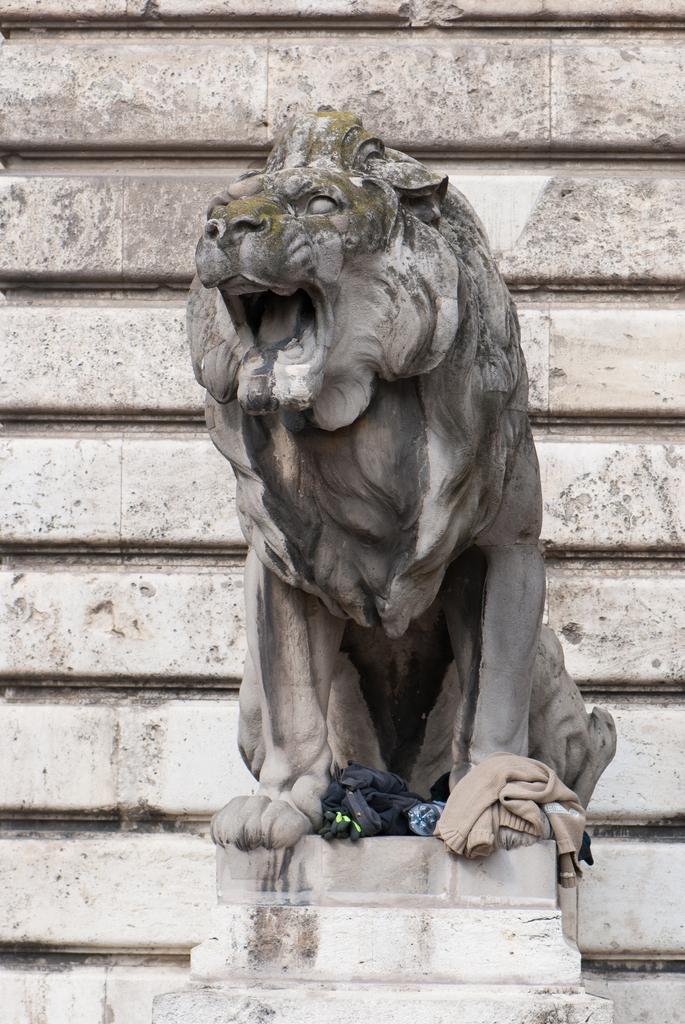What animal is depicted in the image? There is a depiction of a lion in the image. What else can be seen in the image besides the lion? There are clothes and a bottle visible in the image. What is in the background of the image? There is a wall in the background of the image. Where is the lake located in the image? There is no lake present in the image. What type of competition is taking place in the image? There is no competition depicted in the image. 